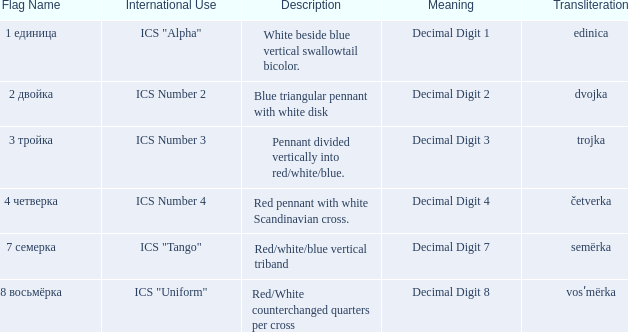What is the name of the flag that means decimal digit 2? 2 двойка. 